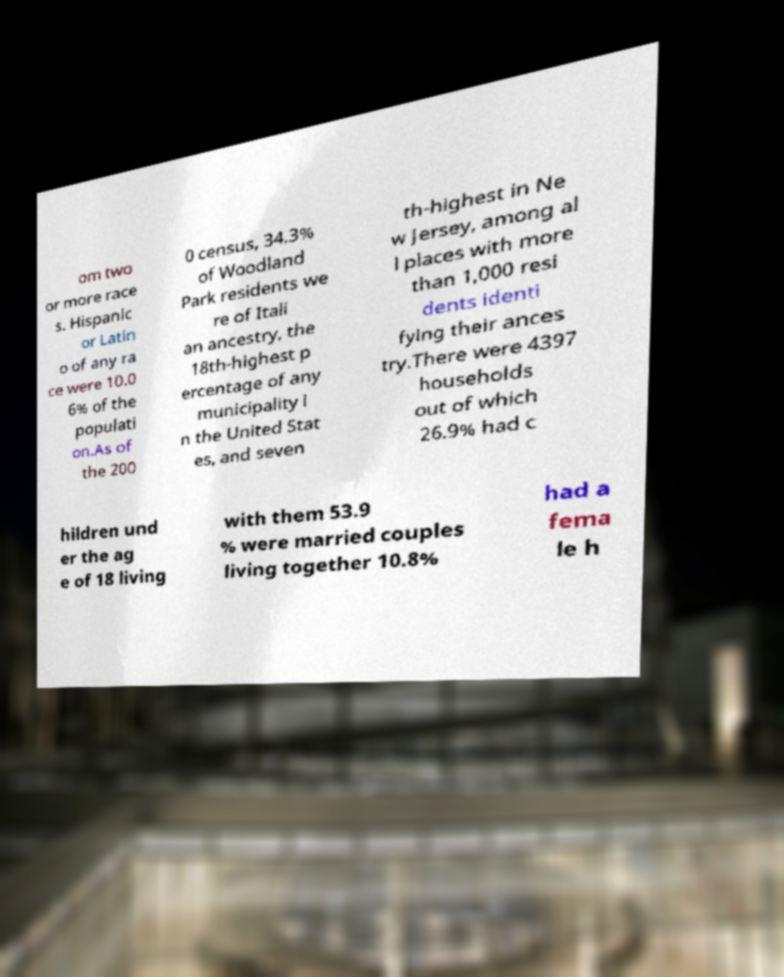Could you extract and type out the text from this image? om two or more race s. Hispanic or Latin o of any ra ce were 10.0 6% of the populati on.As of the 200 0 census, 34.3% of Woodland Park residents we re of Itali an ancestry, the 18th-highest p ercentage of any municipality i n the United Stat es, and seven th-highest in Ne w Jersey, among al l places with more than 1,000 resi dents identi fying their ances try.There were 4397 households out of which 26.9% had c hildren und er the ag e of 18 living with them 53.9 % were married couples living together 10.8% had a fema le h 